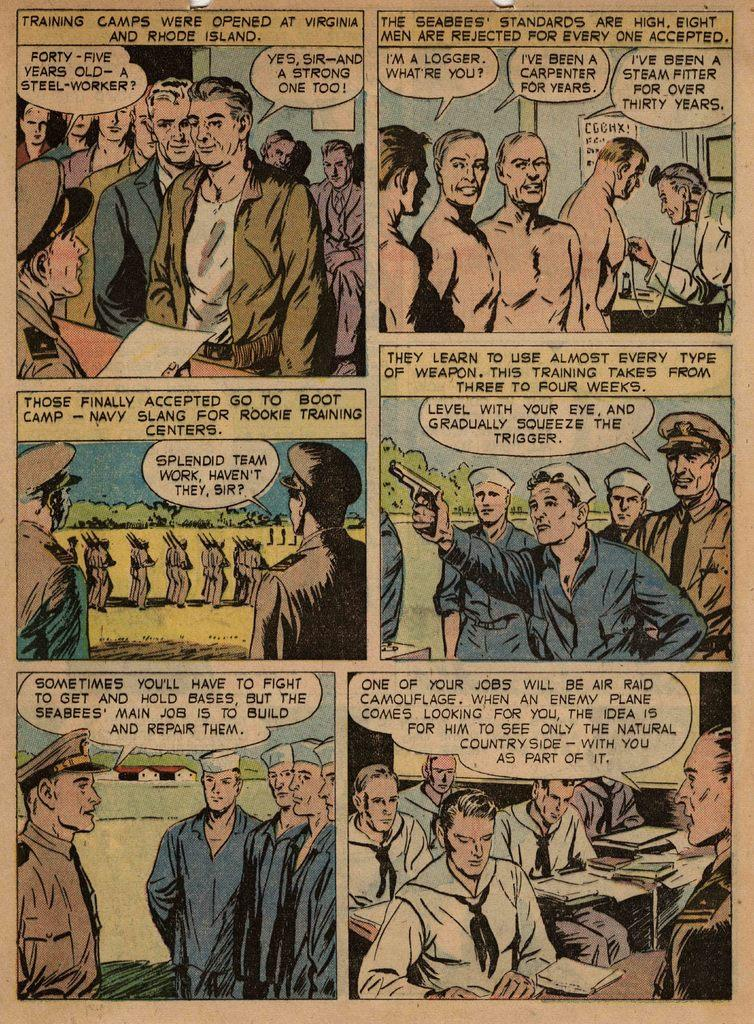<image>
Write a terse but informative summary of the picture. A comic book describing the training camps in Virginia and Rhode Island 